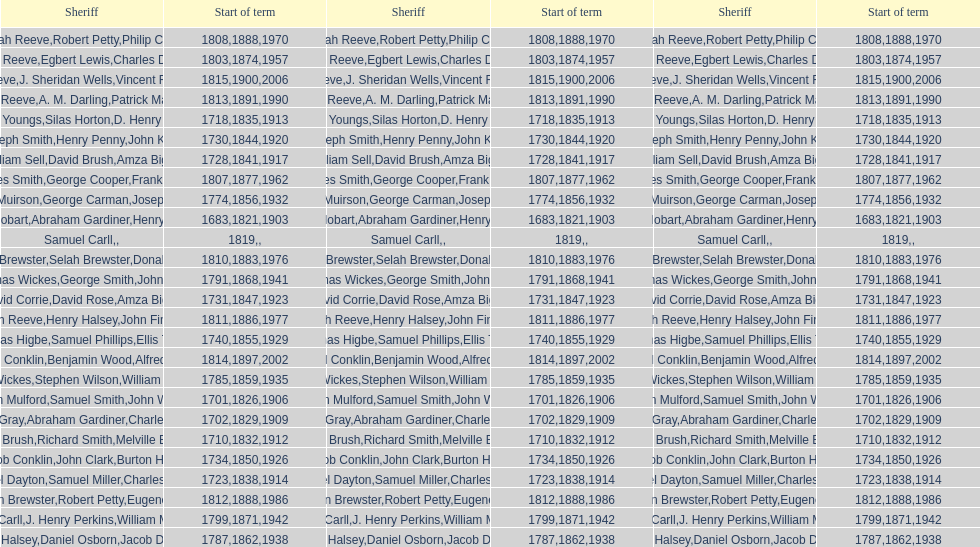Who was the sheriff in suffolk county before amza biggs first term there as sheriff? Charles O'Dell. 